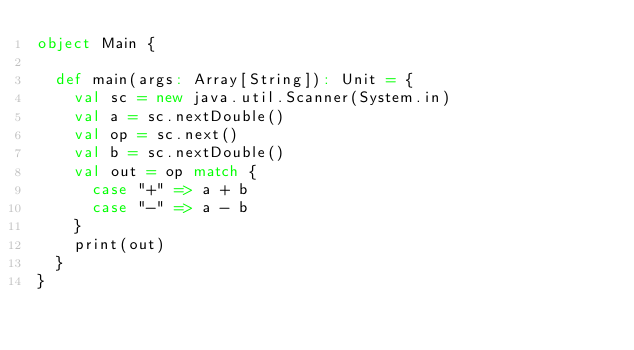<code> <loc_0><loc_0><loc_500><loc_500><_Scala_>object Main {

  def main(args: Array[String]): Unit = {
    val sc = new java.util.Scanner(System.in)
    val a = sc.nextDouble()
    val op = sc.next()
    val b = sc.nextDouble()
    val out = op match {
      case "+" => a + b
      case "-" => a - b
    }
    print(out)
  }
}
</code> 